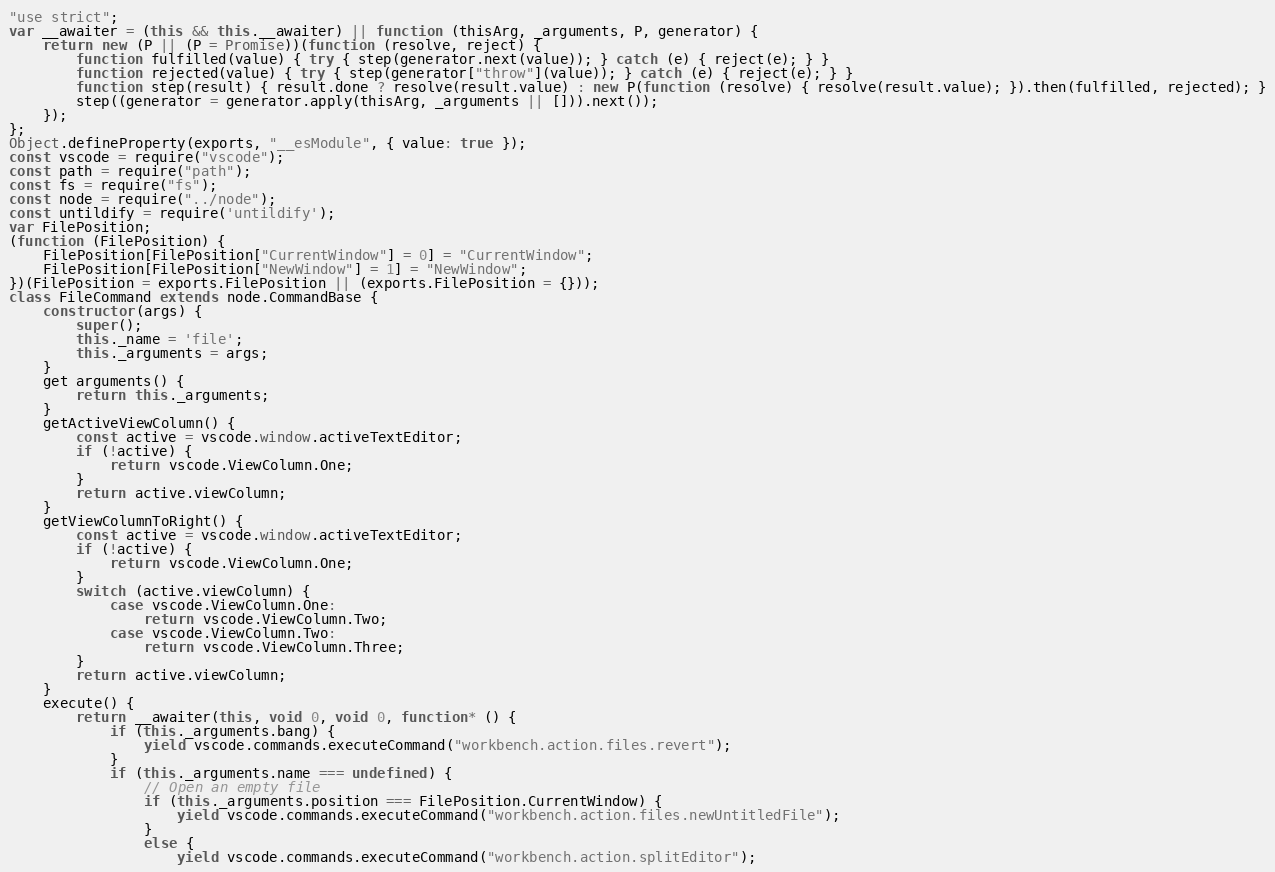<code> <loc_0><loc_0><loc_500><loc_500><_JavaScript_>"use strict";
var __awaiter = (this && this.__awaiter) || function (thisArg, _arguments, P, generator) {
    return new (P || (P = Promise))(function (resolve, reject) {
        function fulfilled(value) { try { step(generator.next(value)); } catch (e) { reject(e); } }
        function rejected(value) { try { step(generator["throw"](value)); } catch (e) { reject(e); } }
        function step(result) { result.done ? resolve(result.value) : new P(function (resolve) { resolve(result.value); }).then(fulfilled, rejected); }
        step((generator = generator.apply(thisArg, _arguments || [])).next());
    });
};
Object.defineProperty(exports, "__esModule", { value: true });
const vscode = require("vscode");
const path = require("path");
const fs = require("fs");
const node = require("../node");
const untildify = require('untildify');
var FilePosition;
(function (FilePosition) {
    FilePosition[FilePosition["CurrentWindow"] = 0] = "CurrentWindow";
    FilePosition[FilePosition["NewWindow"] = 1] = "NewWindow";
})(FilePosition = exports.FilePosition || (exports.FilePosition = {}));
class FileCommand extends node.CommandBase {
    constructor(args) {
        super();
        this._name = 'file';
        this._arguments = args;
    }
    get arguments() {
        return this._arguments;
    }
    getActiveViewColumn() {
        const active = vscode.window.activeTextEditor;
        if (!active) {
            return vscode.ViewColumn.One;
        }
        return active.viewColumn;
    }
    getViewColumnToRight() {
        const active = vscode.window.activeTextEditor;
        if (!active) {
            return vscode.ViewColumn.One;
        }
        switch (active.viewColumn) {
            case vscode.ViewColumn.One:
                return vscode.ViewColumn.Two;
            case vscode.ViewColumn.Two:
                return vscode.ViewColumn.Three;
        }
        return active.viewColumn;
    }
    execute() {
        return __awaiter(this, void 0, void 0, function* () {
            if (this._arguments.bang) {
                yield vscode.commands.executeCommand("workbench.action.files.revert");
            }
            if (this._arguments.name === undefined) {
                // Open an empty file
                if (this._arguments.position === FilePosition.CurrentWindow) {
                    yield vscode.commands.executeCommand("workbench.action.files.newUntitledFile");
                }
                else {
                    yield vscode.commands.executeCommand("workbench.action.splitEditor");</code> 